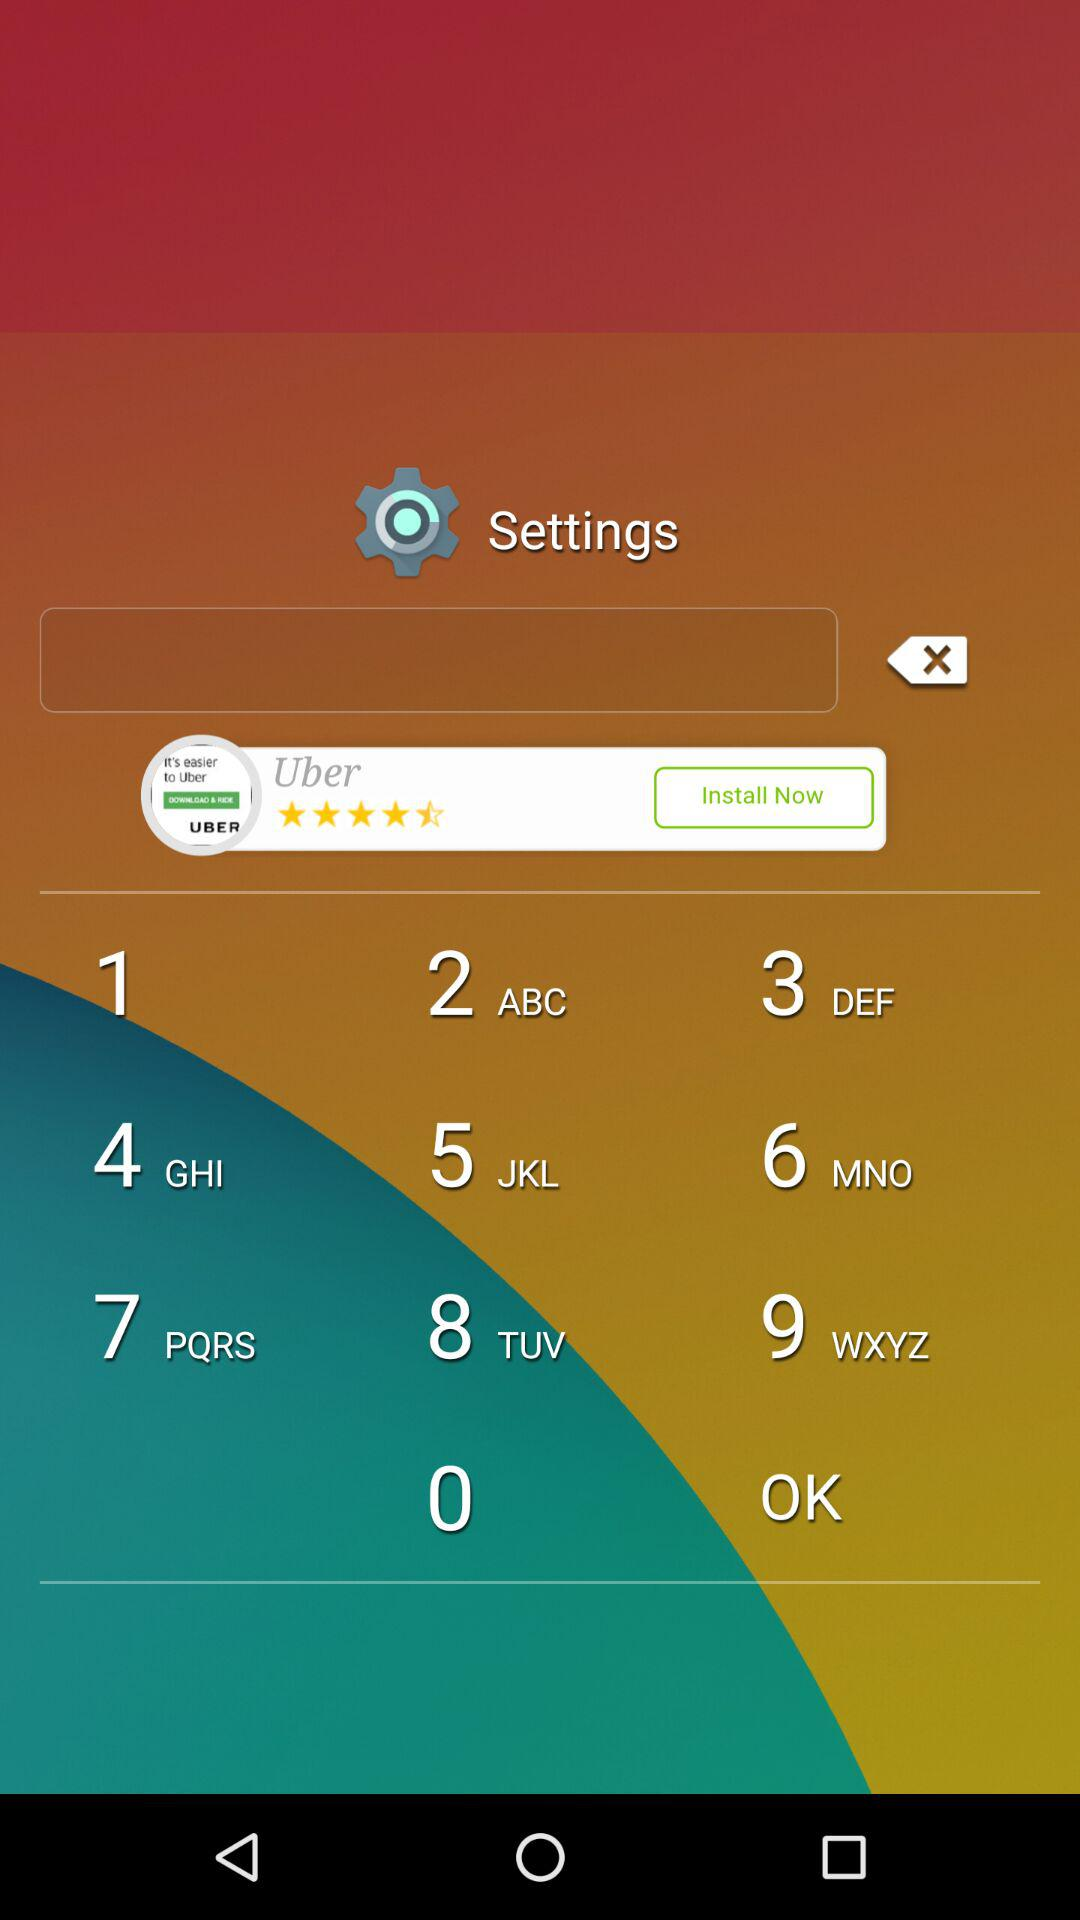What is the duration of the "On Time" scary launch way? The duration of the "On Time" scary launch way is 10 seconds. 